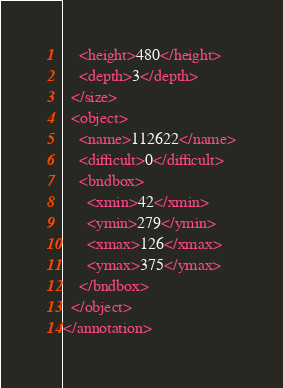Convert code to text. <code><loc_0><loc_0><loc_500><loc_500><_XML_>    <height>480</height>
    <depth>3</depth>
  </size>
  <object>
    <name>112622</name>
    <difficult>0</difficult>
    <bndbox>
      <xmin>42</xmin>
      <ymin>279</ymin>
      <xmax>126</xmax>
      <ymax>375</ymax>
    </bndbox>
  </object>
</annotation></code> 